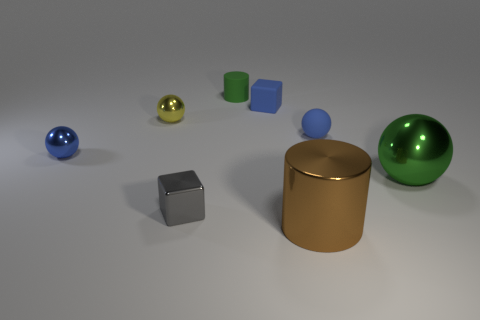Subtract all green spheres. How many spheres are left? 3 Subtract all brown spheres. Subtract all purple cylinders. How many spheres are left? 4 Add 1 big objects. How many objects exist? 9 Subtract all cylinders. How many objects are left? 6 Subtract 0 red cubes. How many objects are left? 8 Subtract all big blue metallic things. Subtract all small metal blocks. How many objects are left? 7 Add 3 tiny blocks. How many tiny blocks are left? 5 Add 5 blue matte cubes. How many blue matte cubes exist? 6 